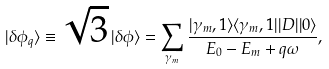Convert formula to latex. <formula><loc_0><loc_0><loc_500><loc_500>| \delta \phi _ { q } \rangle \equiv \sqrt { 3 } \, | \delta \phi \rangle = \sum _ { \gamma _ { m } } \frac { | \gamma _ { m } , 1 \rangle \langle \gamma _ { m } , 1 | | D | | 0 \rangle } { E _ { 0 } - E _ { m } + q \omega } ,</formula> 